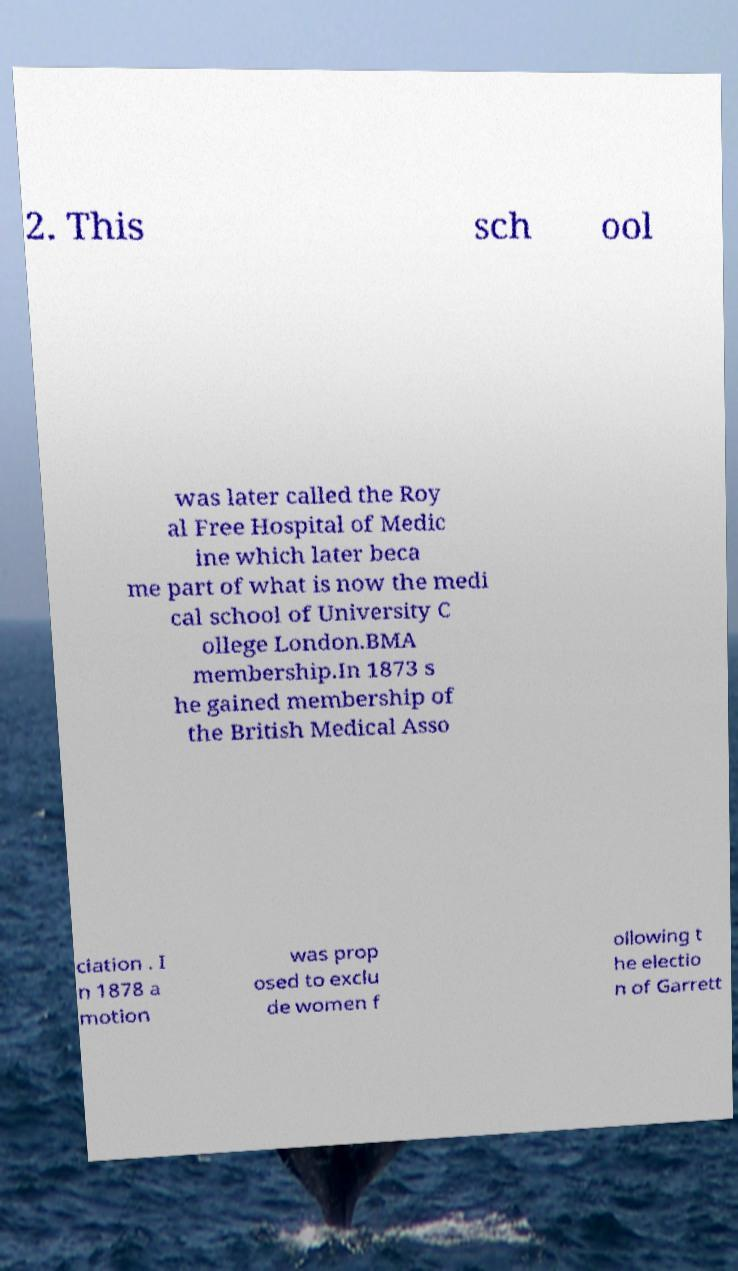For documentation purposes, I need the text within this image transcribed. Could you provide that? 2. This sch ool was later called the Roy al Free Hospital of Medic ine which later beca me part of what is now the medi cal school of University C ollege London.BMA membership.In 1873 s he gained membership of the British Medical Asso ciation . I n 1878 a motion was prop osed to exclu de women f ollowing t he electio n of Garrett 